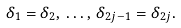<formula> <loc_0><loc_0><loc_500><loc_500>\delta _ { 1 } = \delta _ { 2 } , \, \dots , \, \delta _ { 2 j - 1 } = \delta _ { 2 j } .</formula> 